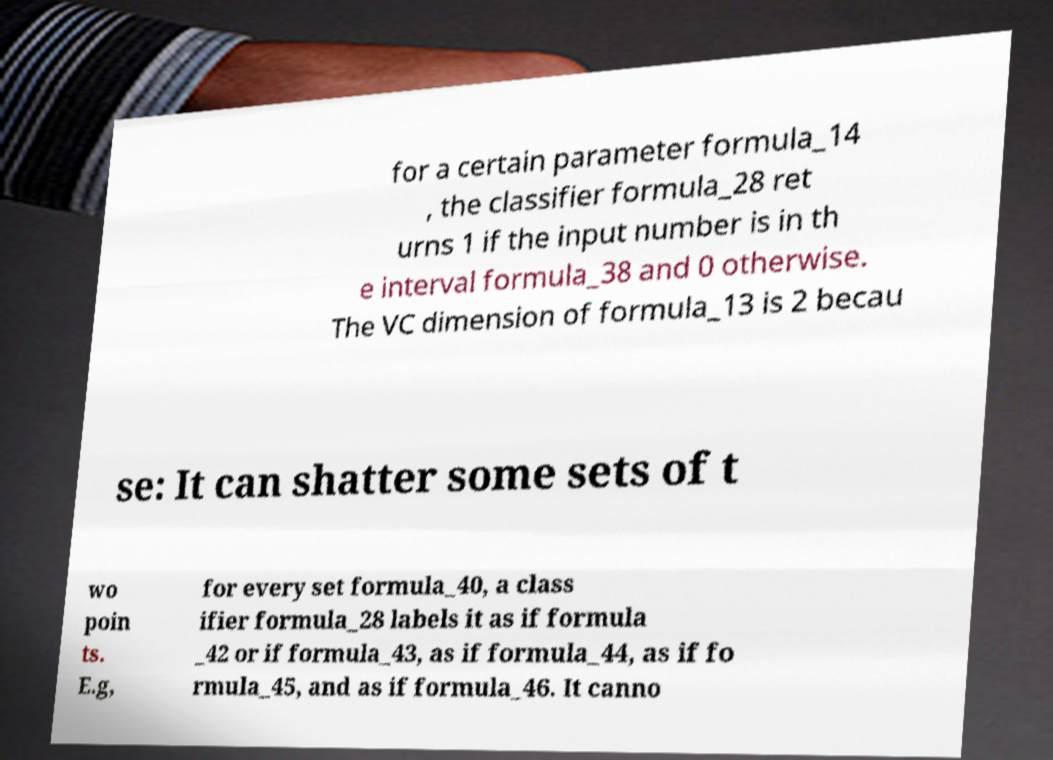For documentation purposes, I need the text within this image transcribed. Could you provide that? for a certain parameter formula_14 , the classifier formula_28 ret urns 1 if the input number is in th e interval formula_38 and 0 otherwise. The VC dimension of formula_13 is 2 becau se: It can shatter some sets of t wo poin ts. E.g, for every set formula_40, a class ifier formula_28 labels it as if formula _42 or if formula_43, as if formula_44, as if fo rmula_45, and as if formula_46. It canno 